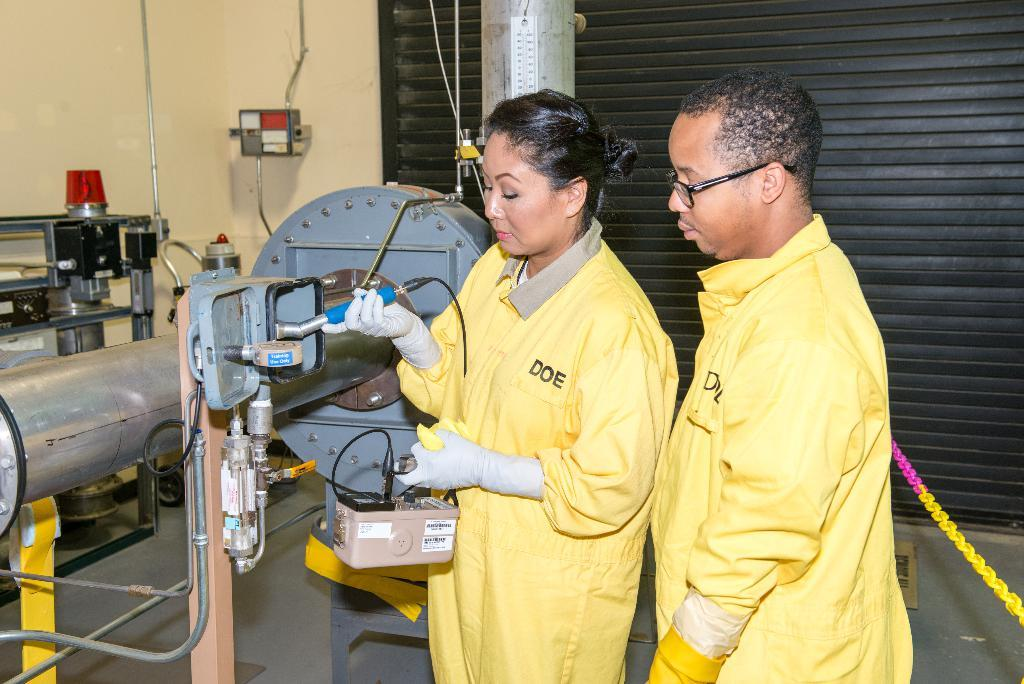How many people are in the image? There are two people in the image. What are the people doing in the image? The people are standing and operating a machine. What can be seen in the background of the image? There is a shutter visible in the background of the image. What type of waste can be seen being produced by the machine in the image? There is no waste being produced by the machine in the image. What emotion might the people be feeling while operating the machine in the image? We cannot determine the emotions of the people in the image based on the provided facts. 